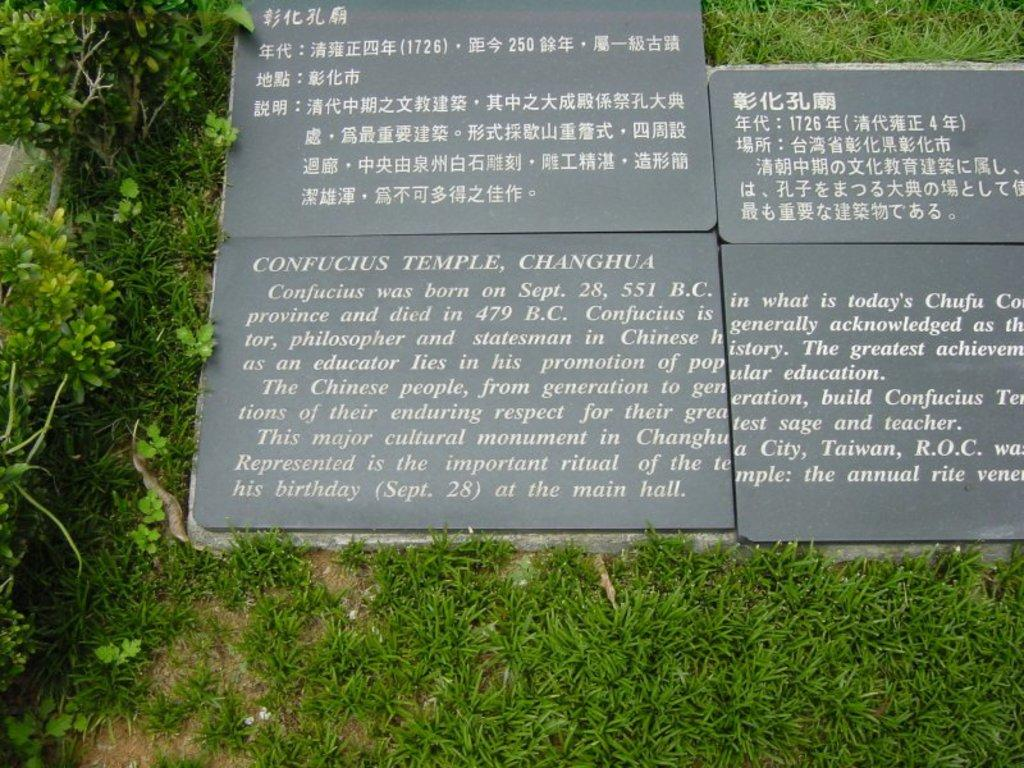What is written or depicted on the marble in the image? There is text on the marble in the image. What type of vegetation can be seen in the image? There are plants visible in the image. What type of humor can be found in the image? There is no humor present in the image; it features text on a marble surface and plants. What language is used in the text on the marble? The language used in the text on the marble cannot be determined from the image alone. 